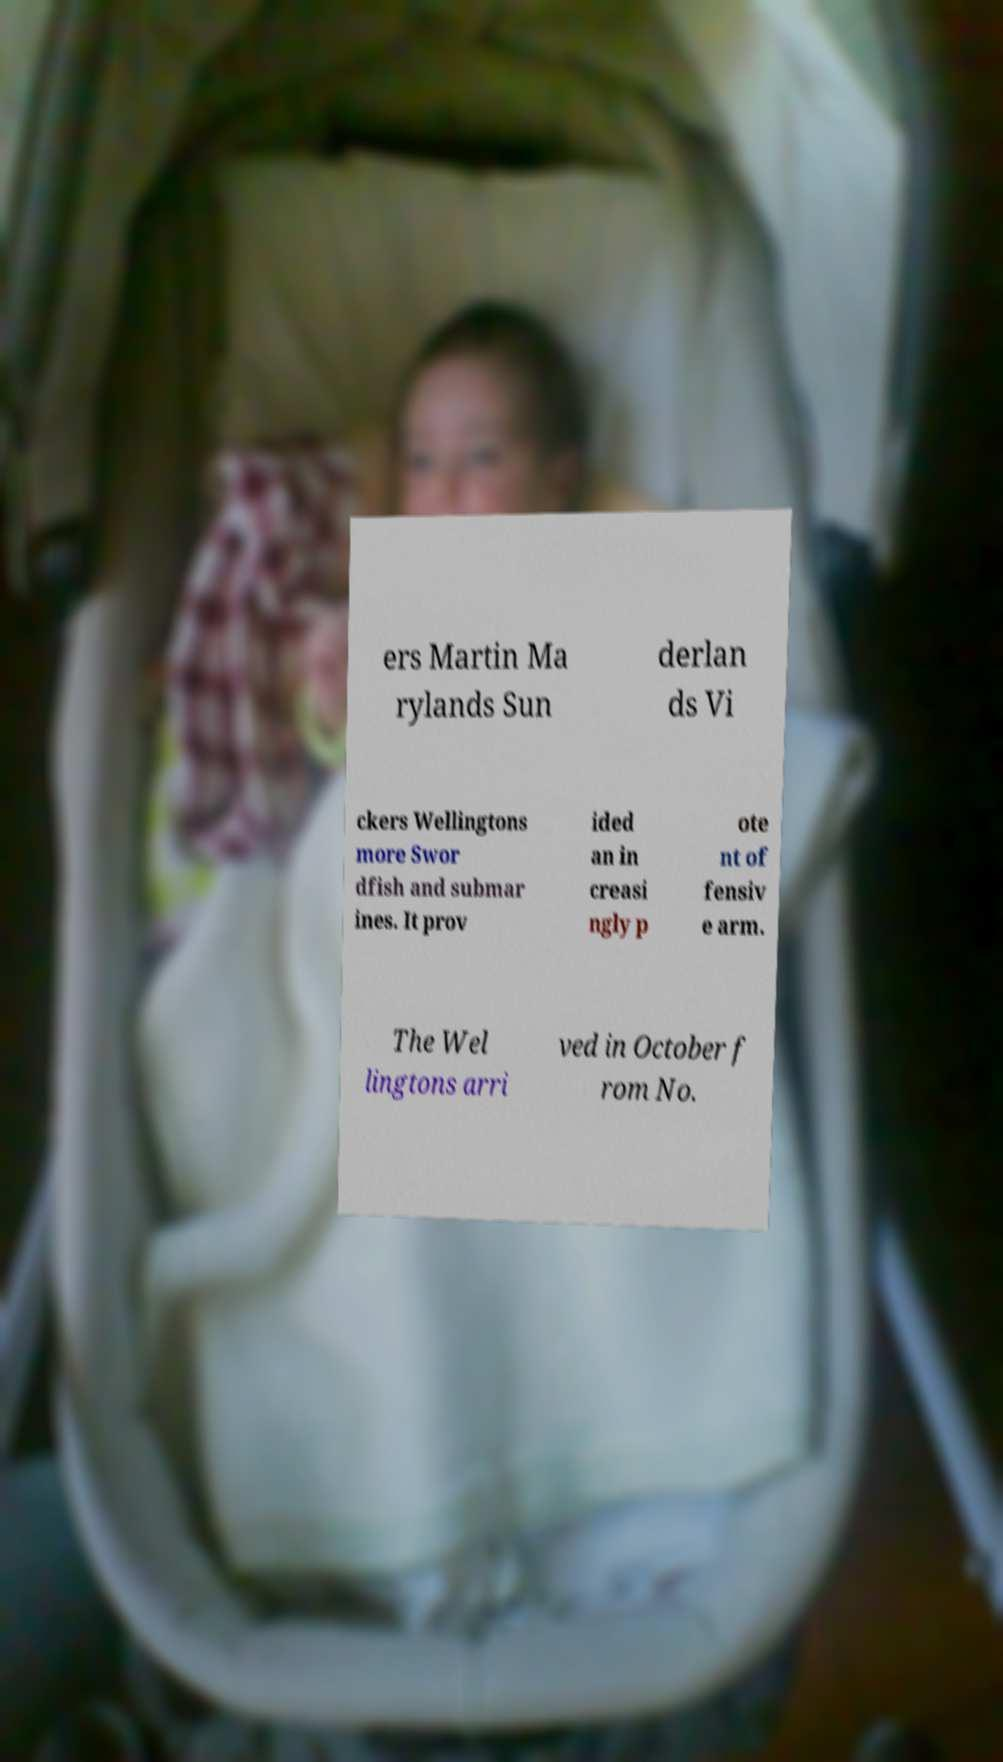Can you accurately transcribe the text from the provided image for me? ers Martin Ma rylands Sun derlan ds Vi ckers Wellingtons more Swor dfish and submar ines. It prov ided an in creasi ngly p ote nt of fensiv e arm. The Wel lingtons arri ved in October f rom No. 